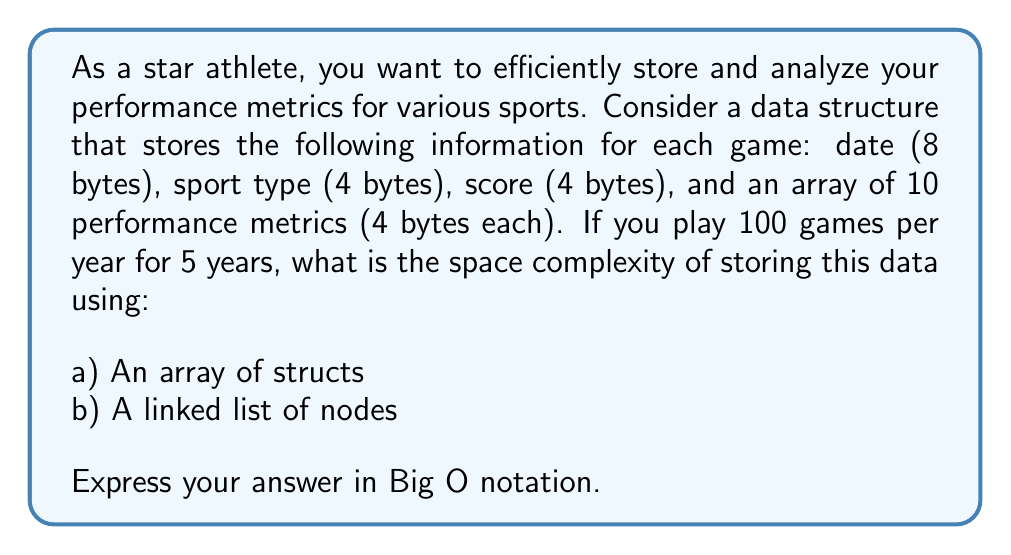Provide a solution to this math problem. Let's break this down step-by-step:

1. Calculate the size of each game record:
   - Date: 8 bytes
   - Sport type: 4 bytes
   - Score: 4 bytes
   - Performance metrics: 10 * 4 bytes = 40 bytes
   - Total: 8 + 4 + 4 + 40 = 56 bytes per game

2. Calculate the total number of games:
   - 100 games per year for 5 years = 500 games

3. Array of structs:
   - An array stores all elements contiguously in memory
   - Space required: 500 * 56 bytes = 28,000 bytes
   - The space complexity is directly proportional to the number of elements
   - Therefore, the space complexity is $O(n)$, where $n$ is the number of games

4. Linked list of nodes:
   - Each node in a linked list contains the data and a pointer to the next node
   - Assuming a 64-bit system, a pointer takes 8 bytes
   - Space required for each node: 56 bytes (data) + 8 bytes (pointer) = 64 bytes
   - Total space: 500 * 64 bytes = 32,000 bytes
   - The space complexity is still directly proportional to the number of elements
   - Therefore, the space complexity is also $O(n)$

Both data structures have the same space complexity in Big O notation, but the linked list uses slightly more memory due to the additional pointers.
Answer: a) Array of structs: $O(n)$
b) Linked list of nodes: $O(n)$

Where $n$ is the number of games stored. 